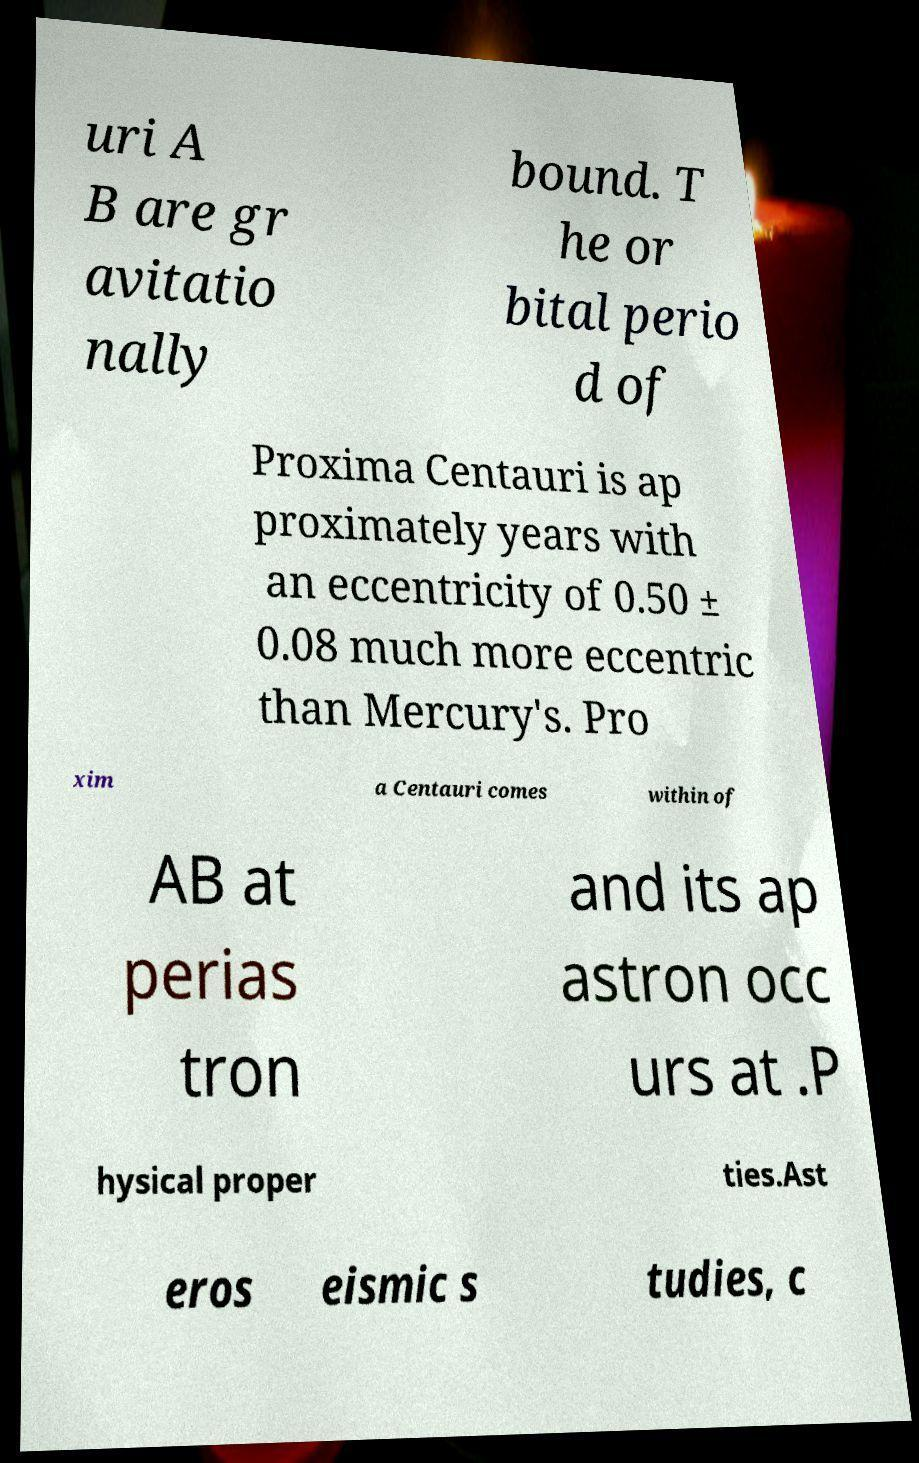I need the written content from this picture converted into text. Can you do that? uri A B are gr avitatio nally bound. T he or bital perio d of Proxima Centauri is ap proximately years with an eccentricity of 0.50 ± 0.08 much more eccentric than Mercury's. Pro xim a Centauri comes within of AB at perias tron and its ap astron occ urs at .P hysical proper ties.Ast eros eismic s tudies, c 